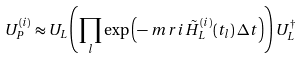<formula> <loc_0><loc_0><loc_500><loc_500>U _ { P } ^ { ( i ) } & \approx U _ { L } \left ( \prod _ { l } \exp \left ( - \ m r { i } \, \tilde { H } ^ { ( i ) } _ { L } ( t _ { l } ) \, \Delta t \right ) \right ) U _ { L } ^ { \dagger } \,</formula> 